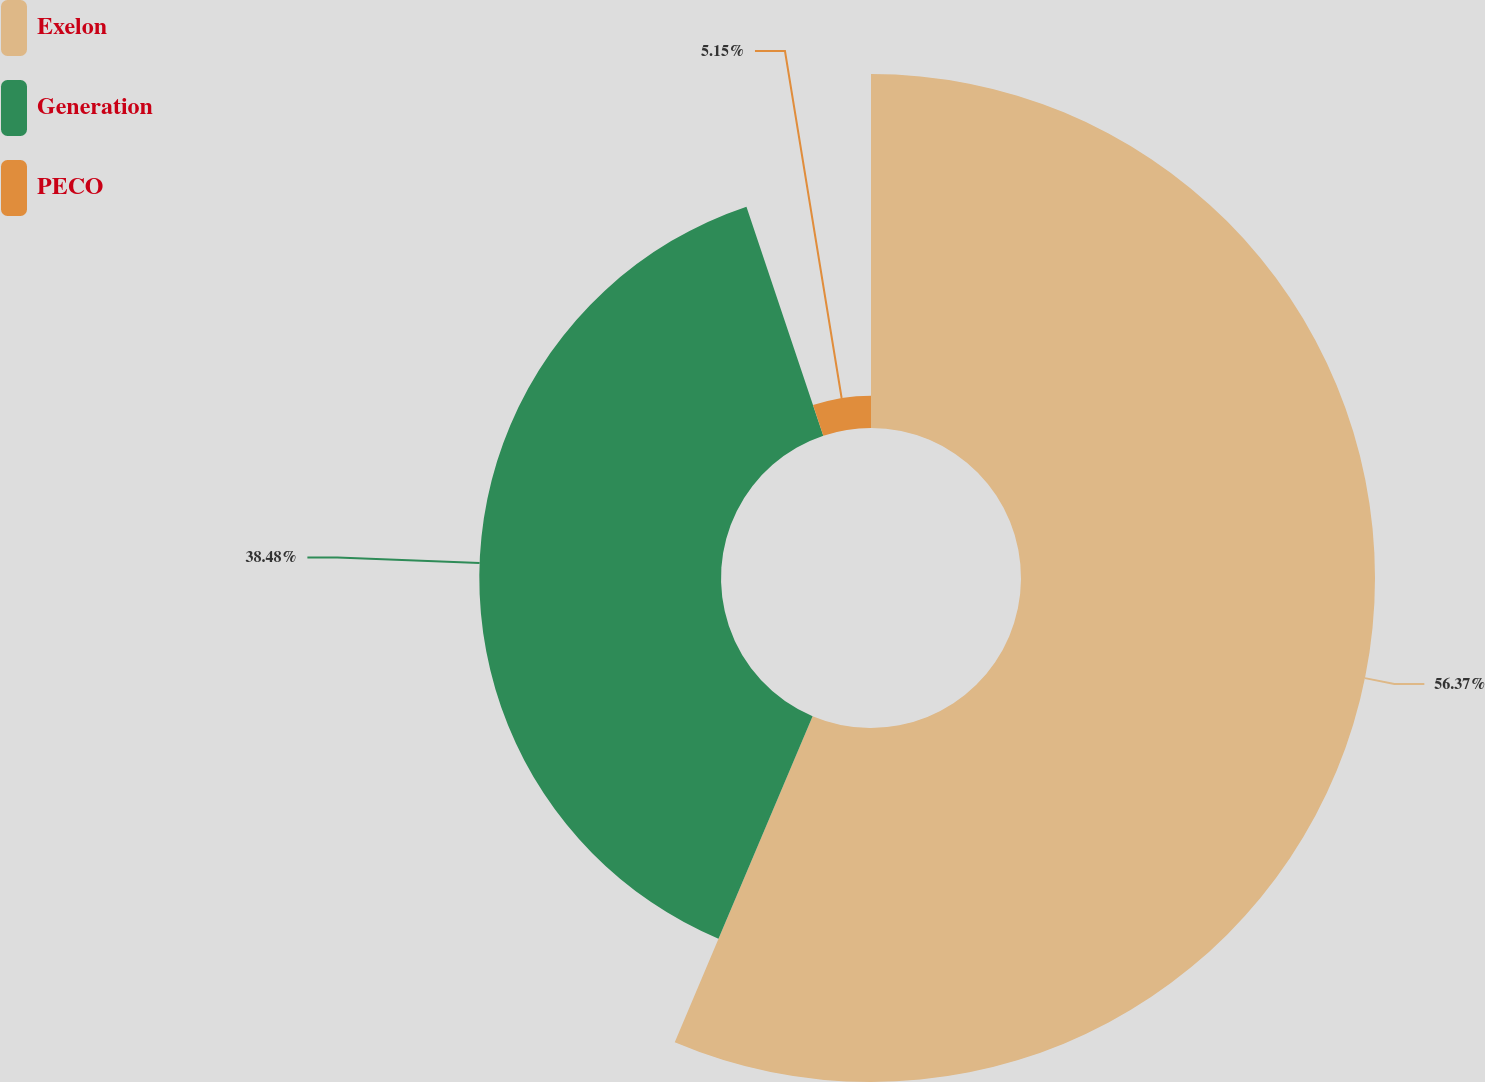<chart> <loc_0><loc_0><loc_500><loc_500><pie_chart><fcel>Exelon<fcel>Generation<fcel>PECO<nl><fcel>56.36%<fcel>38.48%<fcel>5.15%<nl></chart> 